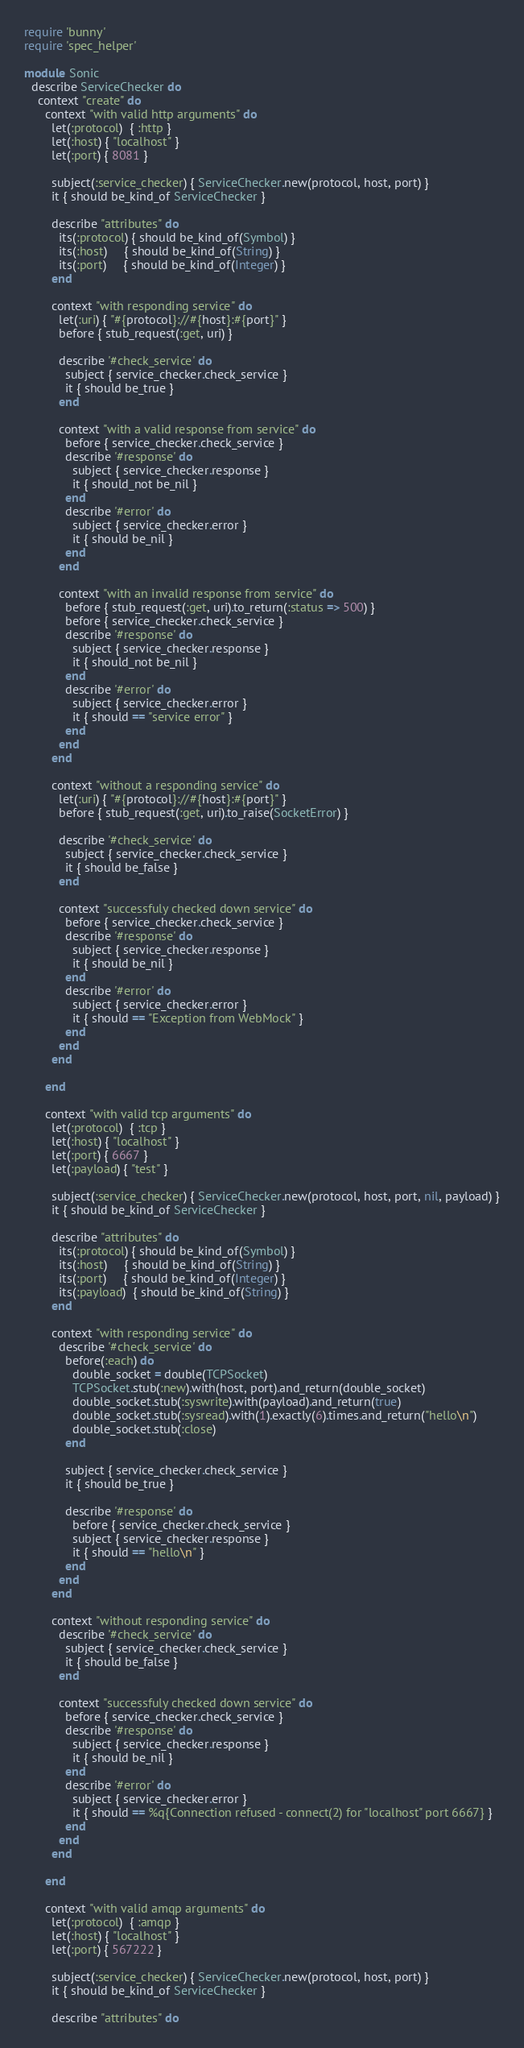Convert code to text. <code><loc_0><loc_0><loc_500><loc_500><_Ruby_>require 'bunny'
require 'spec_helper'

module Sonic
  describe ServiceChecker do
    context "create" do
      context "with valid http arguments" do
        let(:protocol)  { :http }
        let(:host) { "localhost" }
        let(:port) { 8081 }

        subject(:service_checker) { ServiceChecker.new(protocol, host, port) }
        it { should be_kind_of ServiceChecker }

        describe "attributes" do
          its(:protocol) { should be_kind_of(Symbol) }
          its(:host)     { should be_kind_of(String) }
          its(:port)     { should be_kind_of(Integer) }
        end

        context "with responding service" do
          let(:uri) { "#{protocol}://#{host}:#{port}" }
          before { stub_request(:get, uri) }

          describe '#check_service' do
            subject { service_checker.check_service }
            it { should be_true }
          end

          context "with a valid response from service" do
            before { service_checker.check_service }
            describe '#response' do
              subject { service_checker.response }
              it { should_not be_nil }
            end
            describe '#error' do
              subject { service_checker.error }
              it { should be_nil }
            end
          end

          context "with an invalid response from service" do
            before { stub_request(:get, uri).to_return(:status => 500) }
            before { service_checker.check_service }
            describe '#response' do
              subject { service_checker.response }
              it { should_not be_nil }
            end
            describe '#error' do
              subject { service_checker.error }
              it { should == "service error" }
            end
          end
        end

        context "without a responding service" do
          let(:uri) { "#{protocol}://#{host}:#{port}" }
          before { stub_request(:get, uri).to_raise(SocketError) }

          describe '#check_service' do
            subject { service_checker.check_service }
            it { should be_false }
          end

          context "successfuly checked down service" do
            before { service_checker.check_service }
            describe '#response' do
              subject { service_checker.response }
              it { should be_nil }
            end
            describe '#error' do
              subject { service_checker.error }
              it { should == "Exception from WebMock" }
            end
          end
        end

      end

      context "with valid tcp arguments" do
        let(:protocol)  { :tcp }
        let(:host) { "localhost" }
        let(:port) { 6667 }
        let(:payload) { "test" }

        subject(:service_checker) { ServiceChecker.new(protocol, host, port, nil, payload) }
        it { should be_kind_of ServiceChecker }

        describe "attributes" do
          its(:protocol) { should be_kind_of(Symbol) }
          its(:host)     { should be_kind_of(String) }
          its(:port)     { should be_kind_of(Integer) }
          its(:payload)  { should be_kind_of(String) }
        end

        context "with responding service" do
          describe '#check_service' do
            before(:each) do
              double_socket = double(TCPSocket)
              TCPSocket.stub(:new).with(host, port).and_return(double_socket)
              double_socket.stub(:syswrite).with(payload).and_return(true)
              double_socket.stub(:sysread).with(1).exactly(6).times.and_return("hello\n")
              double_socket.stub(:close)
            end

            subject { service_checker.check_service }
            it { should be_true }

            describe '#response' do
              before { service_checker.check_service }
              subject { service_checker.response }
              it { should == "hello\n" }
            end
          end
        end

        context "without responding service" do
          describe '#check_service' do
            subject { service_checker.check_service }
            it { should be_false }
          end

          context "successfuly checked down service" do
            before { service_checker.check_service }
            describe '#response' do
              subject { service_checker.response }
              it { should be_nil }
            end
            describe '#error' do
              subject { service_checker.error }
              it { should == %q{Connection refused - connect(2) for "localhost" port 6667} }
            end
          end
        end

      end

      context "with valid amqp arguments" do
        let(:protocol)  { :amqp }
        let(:host) { "localhost" }
        let(:port) { 567222 }

        subject(:service_checker) { ServiceChecker.new(protocol, host, port) }
        it { should be_kind_of ServiceChecker }

        describe "attributes" do</code> 